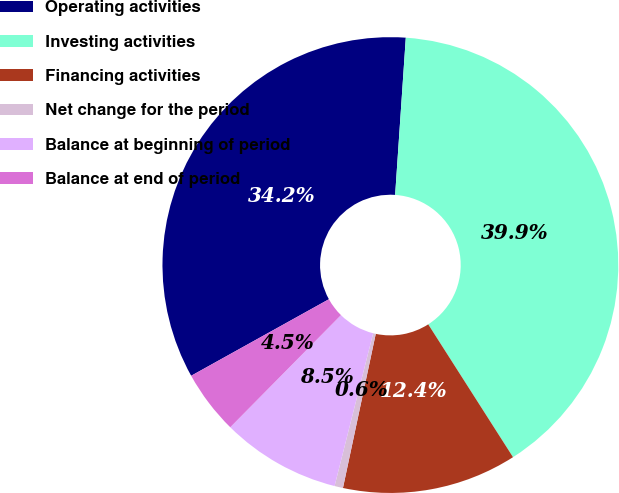Convert chart to OTSL. <chart><loc_0><loc_0><loc_500><loc_500><pie_chart><fcel>Operating activities<fcel>Investing activities<fcel>Financing activities<fcel>Net change for the period<fcel>Balance at beginning of period<fcel>Balance at end of period<nl><fcel>34.15%<fcel>39.88%<fcel>12.38%<fcel>0.6%<fcel>8.46%<fcel>4.53%<nl></chart> 